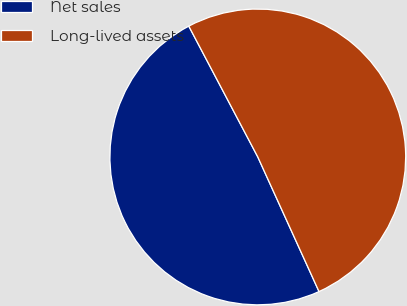Convert chart. <chart><loc_0><loc_0><loc_500><loc_500><pie_chart><fcel>Net sales<fcel>Long-lived assets<nl><fcel>49.07%<fcel>50.93%<nl></chart> 